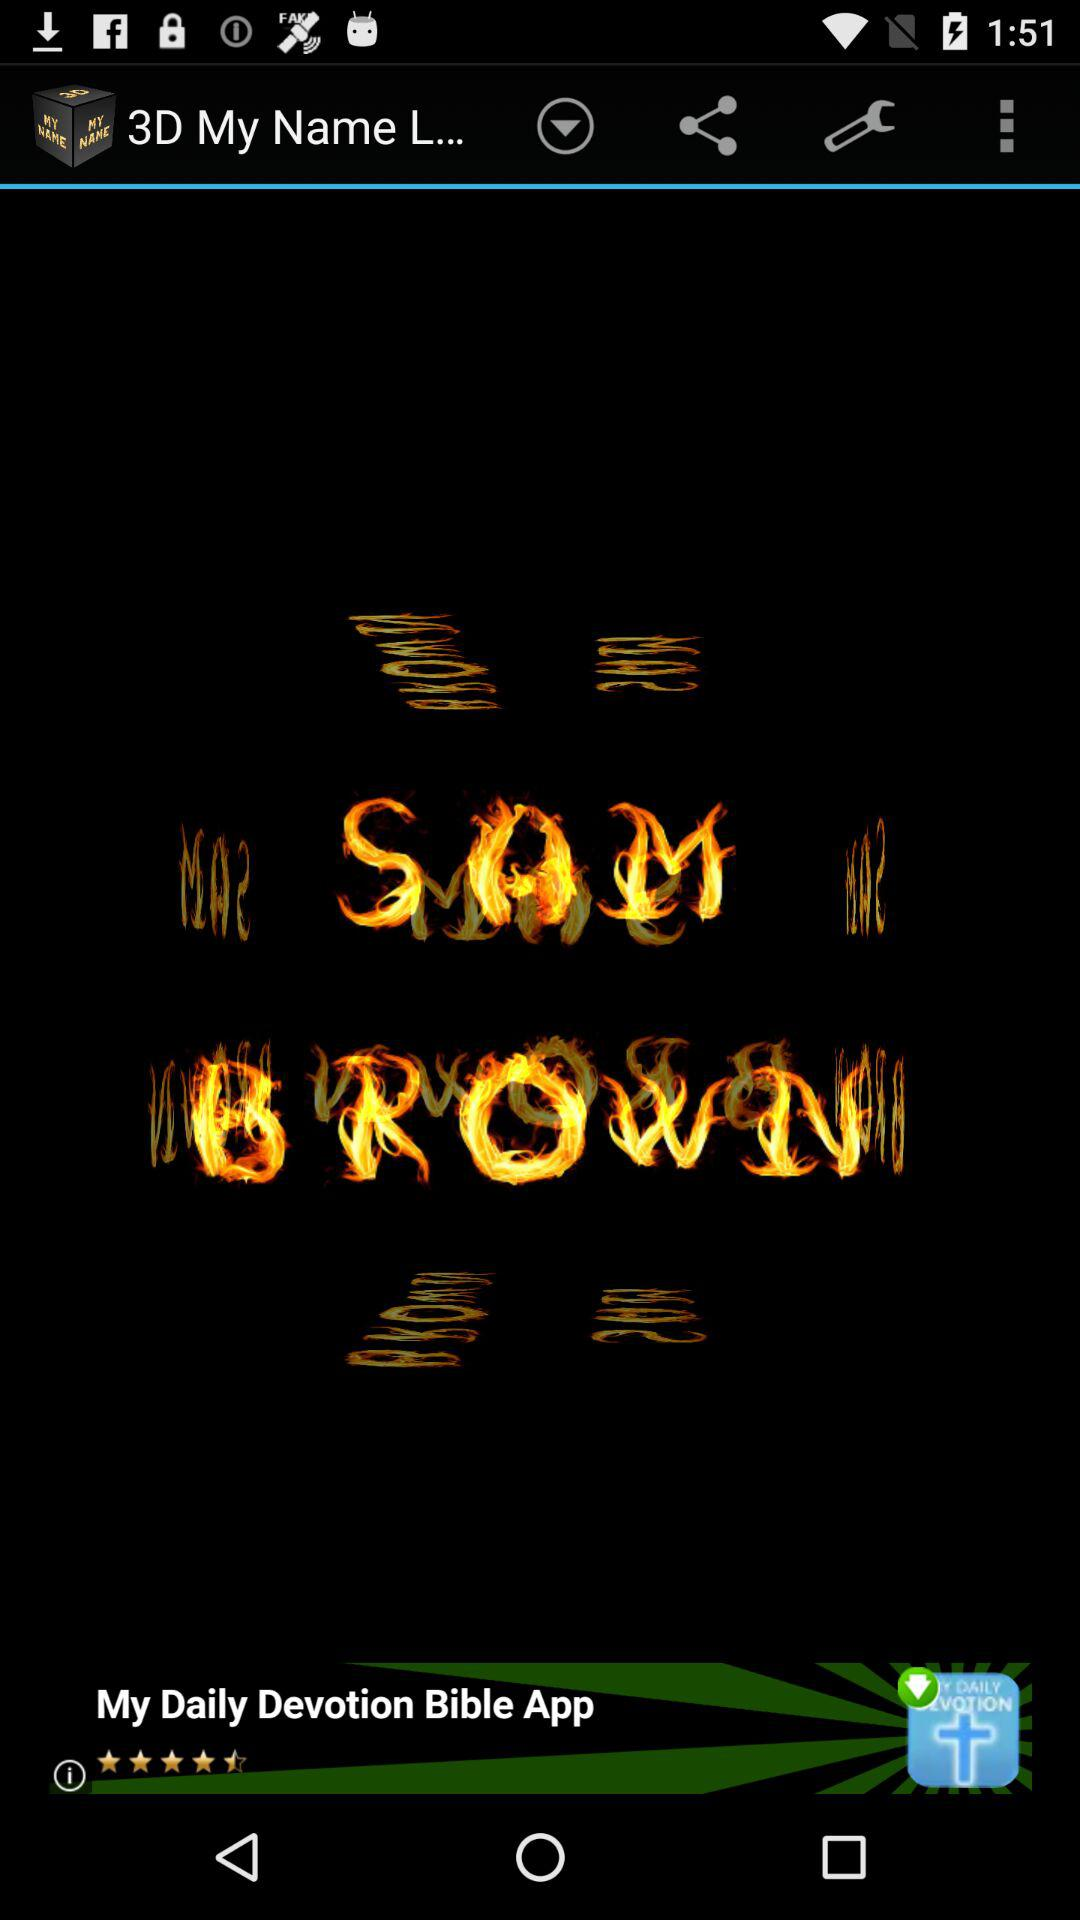What is the version of this application?
When the provided information is insufficient, respond with <no answer>. <no answer> 